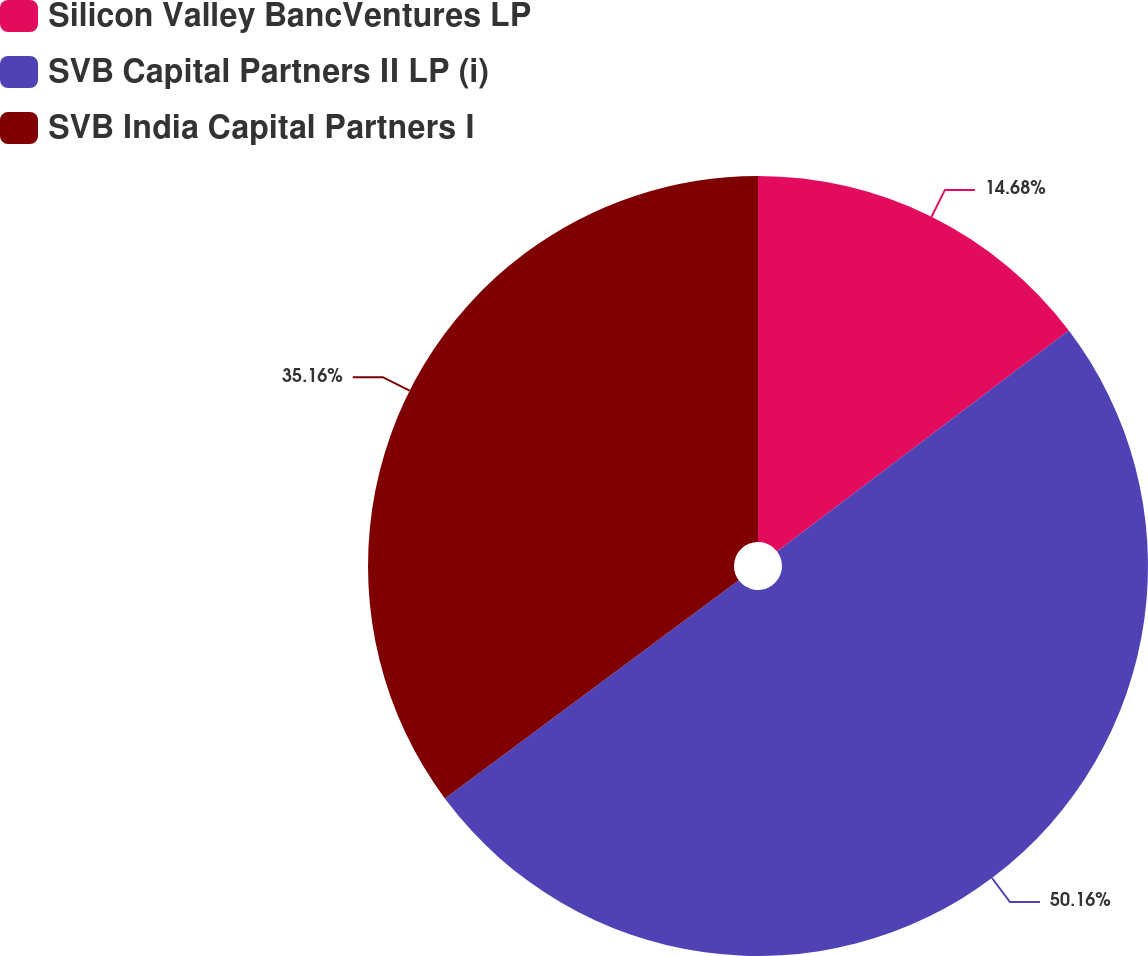<chart> <loc_0><loc_0><loc_500><loc_500><pie_chart><fcel>Silicon Valley BancVentures LP<fcel>SVB Capital Partners II LP (i)<fcel>SVB India Capital Partners I<nl><fcel>14.68%<fcel>50.16%<fcel>35.16%<nl></chart> 